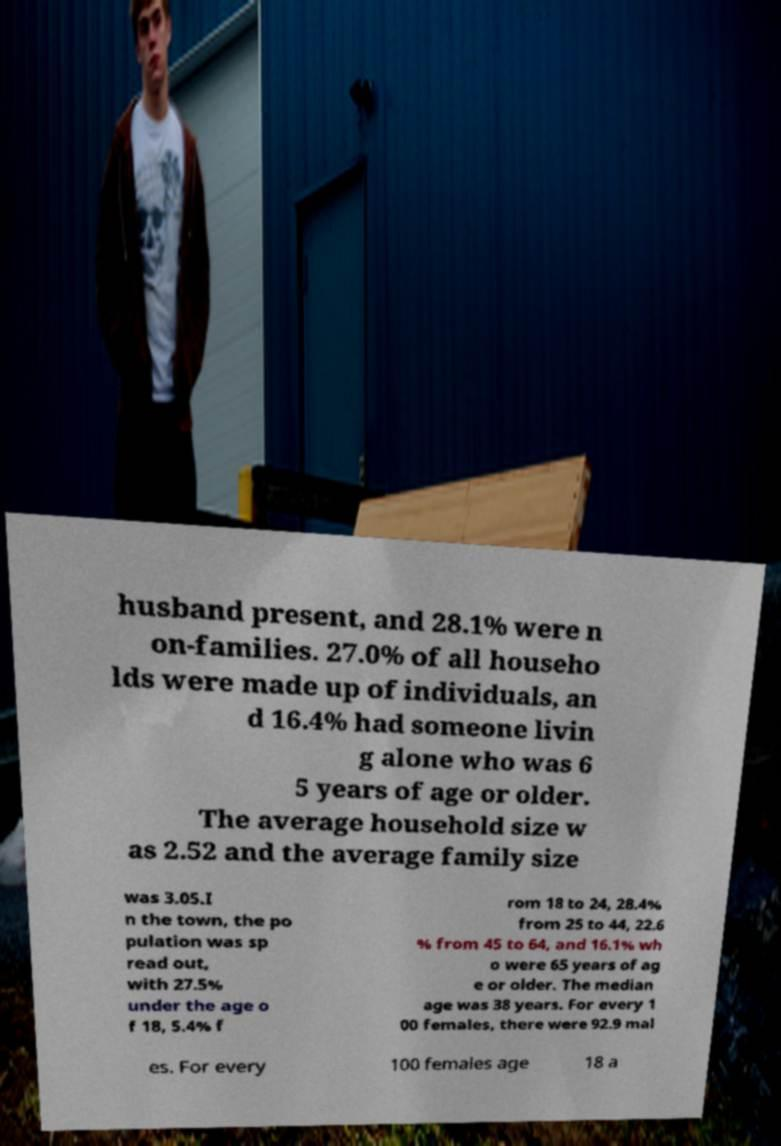What messages or text are displayed in this image? I need them in a readable, typed format. husband present, and 28.1% were n on-families. 27.0% of all househo lds were made up of individuals, an d 16.4% had someone livin g alone who was 6 5 years of age or older. The average household size w as 2.52 and the average family size was 3.05.I n the town, the po pulation was sp read out, with 27.5% under the age o f 18, 5.4% f rom 18 to 24, 28.4% from 25 to 44, 22.6 % from 45 to 64, and 16.1% wh o were 65 years of ag e or older. The median age was 38 years. For every 1 00 females, there were 92.9 mal es. For every 100 females age 18 a 